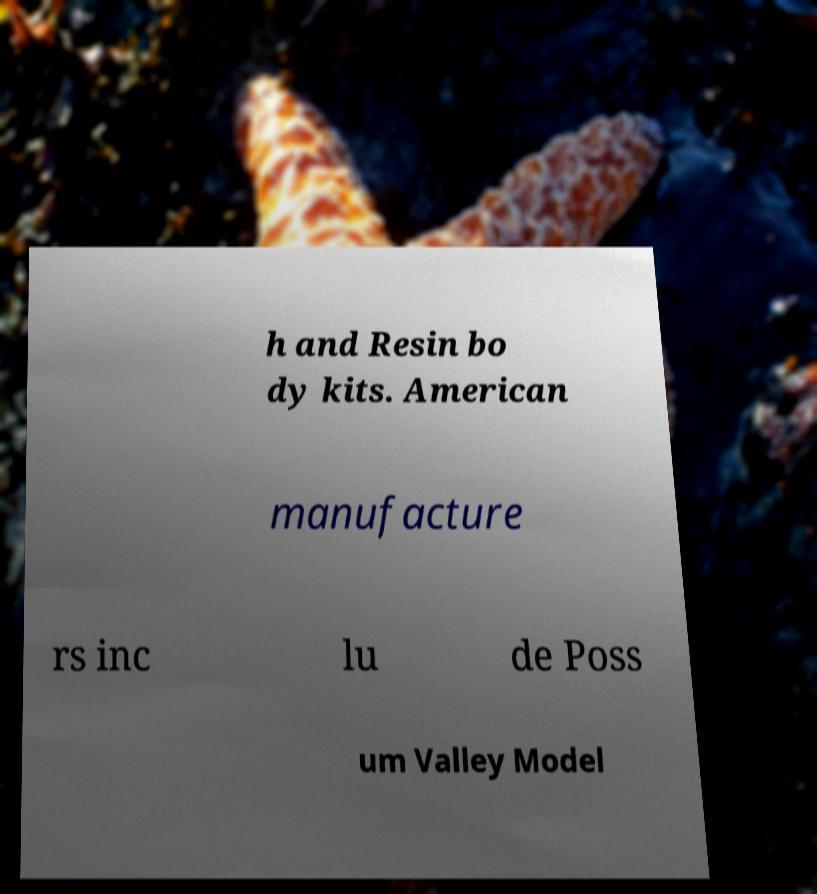There's text embedded in this image that I need extracted. Can you transcribe it verbatim? h and Resin bo dy kits. American manufacture rs inc lu de Poss um Valley Model 